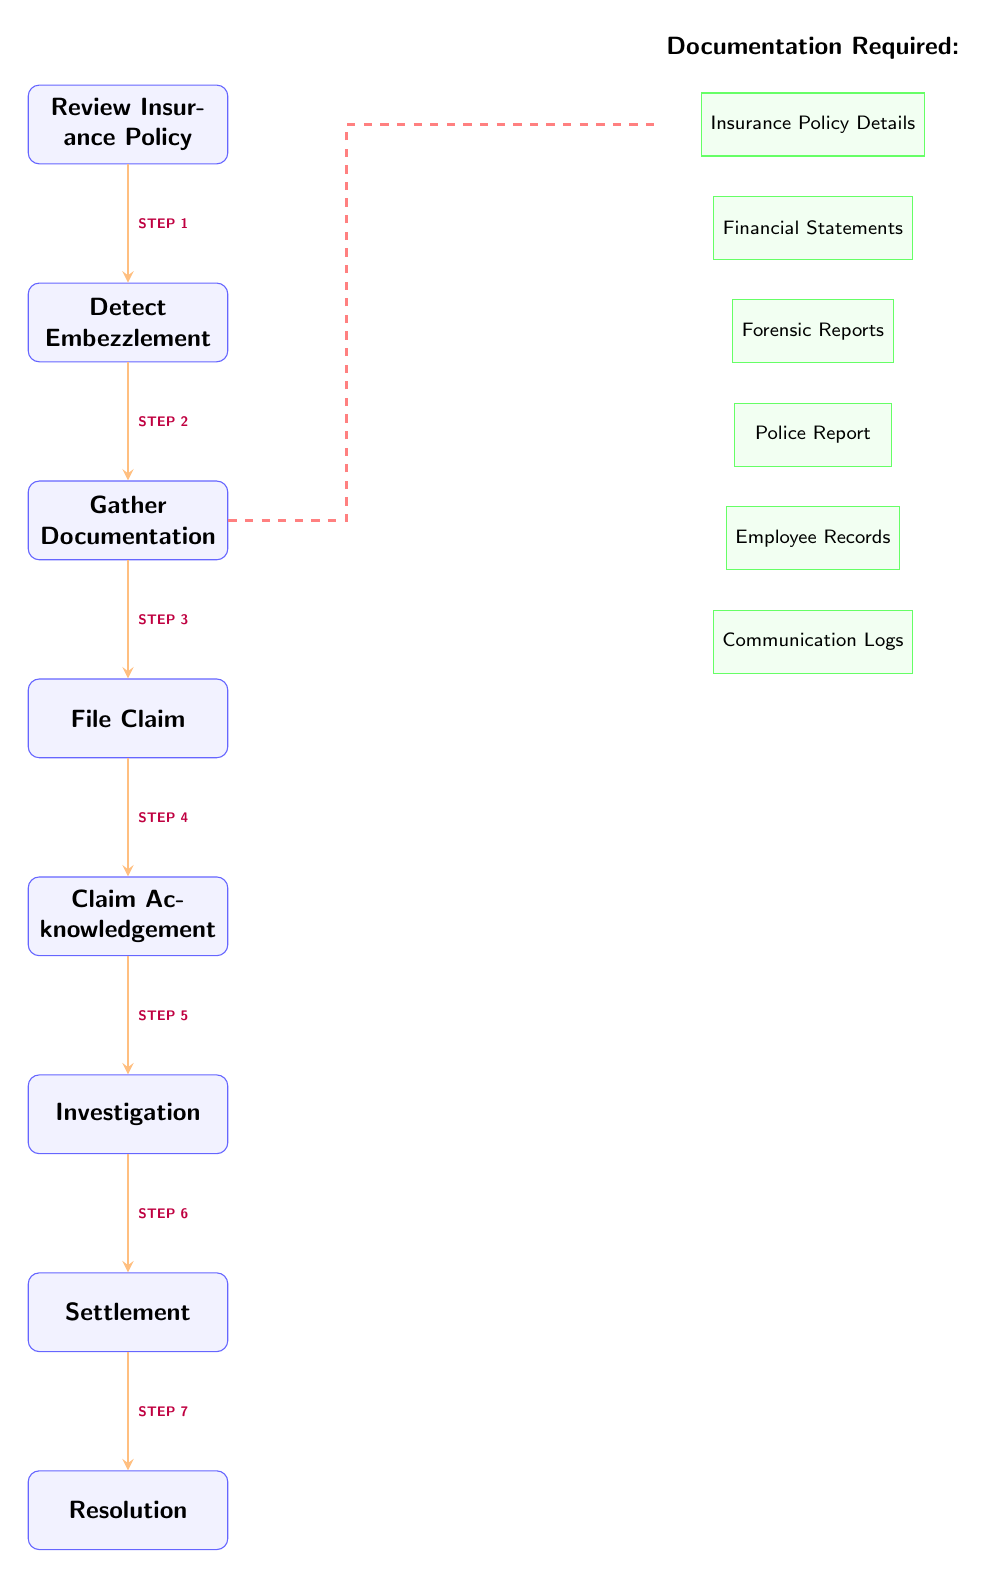What is the first step in the claim process? The first step as shown in the diagram is "Review Insurance Policy," which is directly at the top of the claim process flow.
Answer: Review Insurance Policy How many documentation items are required? The diagram shows a total of six documentation items listed next to the "Gather Documentation" process.
Answer: Six What is the last step in the claim process? The last step in the diagram is "Resolution," which comes after "Settlement."
Answer: Resolution What documentation follows the "Forensic Reports"? According to the layout in the diagram, the documentation that follows "Forensic Reports" is "Police Report."
Answer: Police Report How many steps are involved in the claim process, not including documentation? Counting from "Review Insurance Policy" to "Resolution," the diagram shows seven distinct steps involved in the claim process.
Answer: Seven What is the relationship between the "Gather Documentation" process and the documentation items? The "Gather Documentation" process requires multiple documents to proceed, as indicated by the dashed red line connecting it to the documentation items listed on the right.
Answer: Documentation requirement What is the primary purpose of the "Investigation" step? While the diagram does not explicitly state the purpose, it can be inferred that this step is likely focused on evaluating the gathered documentation and circumstances surrounding embezzlement.
Answer: Evaluate claims What type of document is "Communication Logs"? In the diagram, "Communication Logs" is categorized as a documentation item, which falls under the requirement for supporting the claim process.
Answer: Documentation Which step follows "Claim Acknowledgement"? The diagram shows that "Investigation" is the subsequent step after "Claim Acknowledgement."
Answer: Investigation 